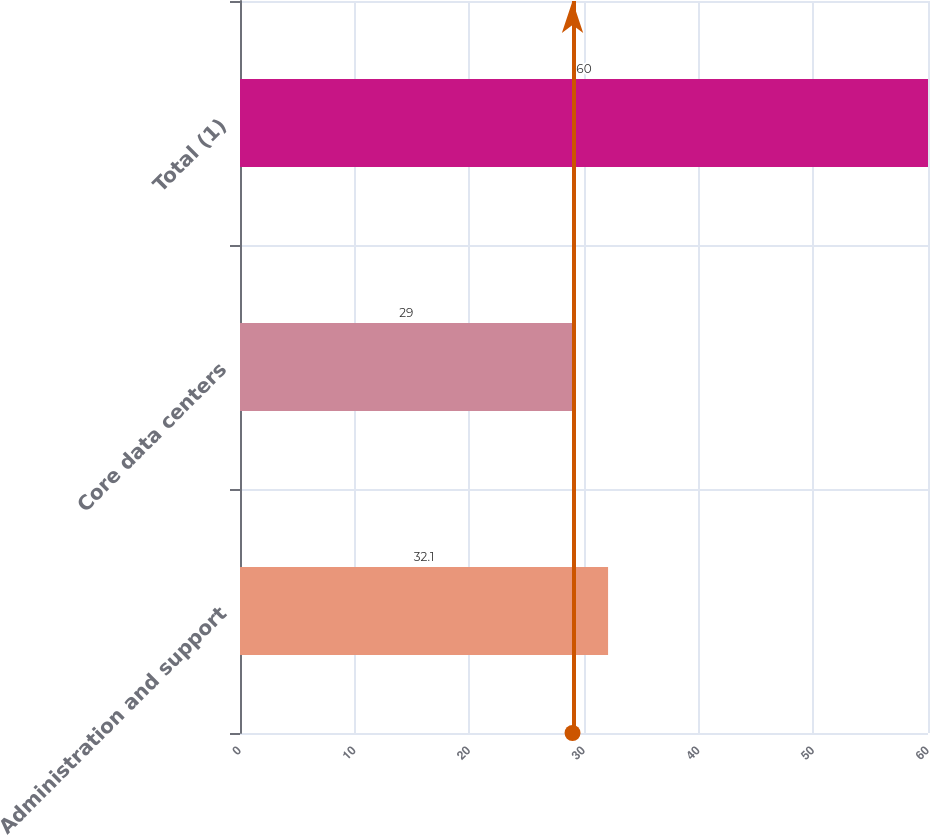<chart> <loc_0><loc_0><loc_500><loc_500><bar_chart><fcel>Administration and support<fcel>Core data centers<fcel>Total (1)<nl><fcel>32.1<fcel>29<fcel>60<nl></chart> 